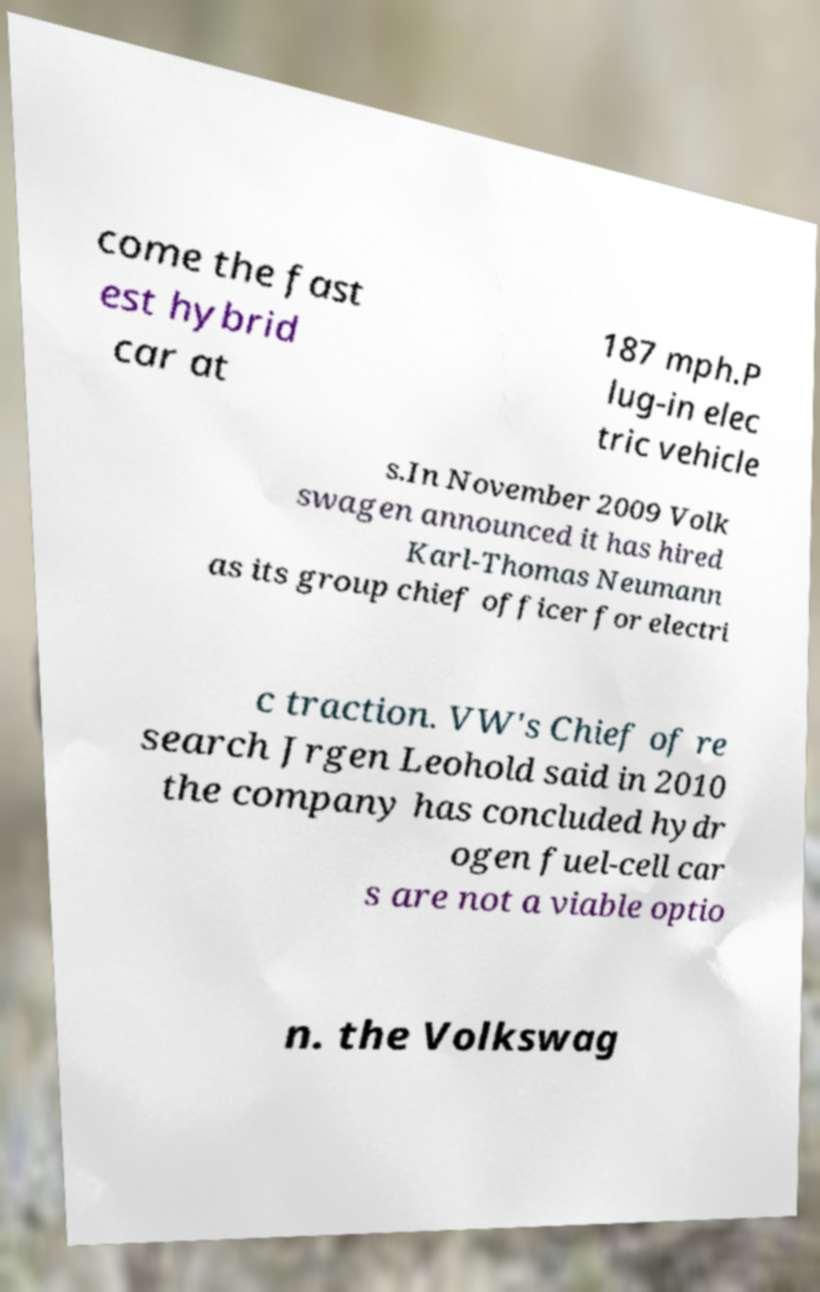Please read and relay the text visible in this image. What does it say? come the fast est hybrid car at 187 mph.P lug-in elec tric vehicle s.In November 2009 Volk swagen announced it has hired Karl-Thomas Neumann as its group chief officer for electri c traction. VW's Chief of re search Jrgen Leohold said in 2010 the company has concluded hydr ogen fuel-cell car s are not a viable optio n. the Volkswag 